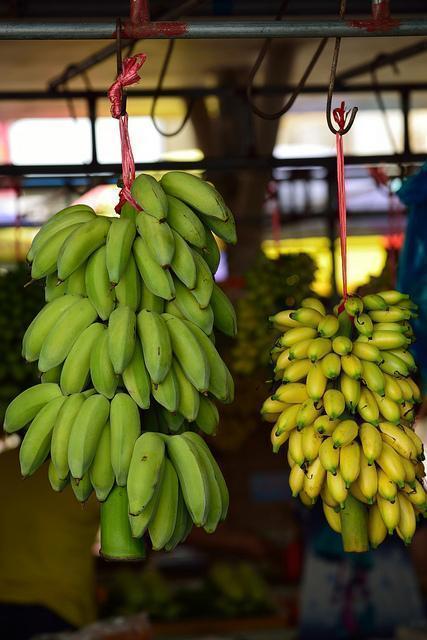Where are these items sold?
Answer the question by selecting the correct answer among the 4 following choices and explain your choice with a short sentence. The answer should be formatted with the following format: `Answer: choice
Rationale: rationale.`
Options: Shoprite, hobby lobby, home depot, best buy. Answer: shoprite.
Rationale: Fruit is typically on sale at grocery stores, and shoprite is a grocery chain. 